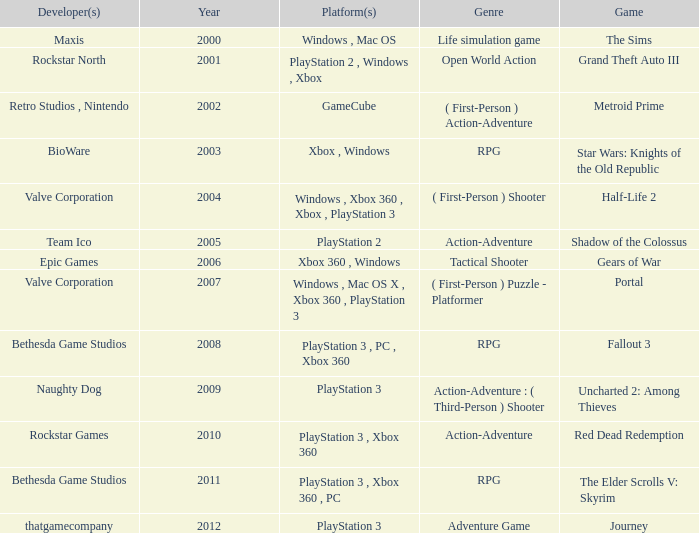What's the platform that has Rockstar Games as the developer? PlayStation 3 , Xbox 360. 